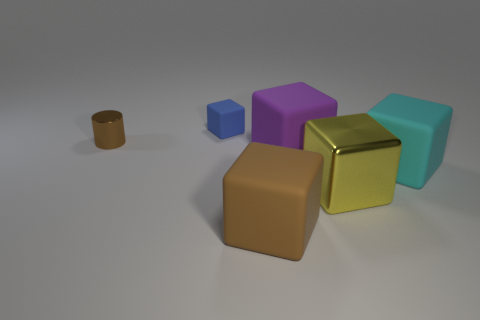How many other objects are there of the same shape as the purple rubber thing? There is one object that shares the same cubic shape as the purple rubber item, which is the blue cube located to its left. 